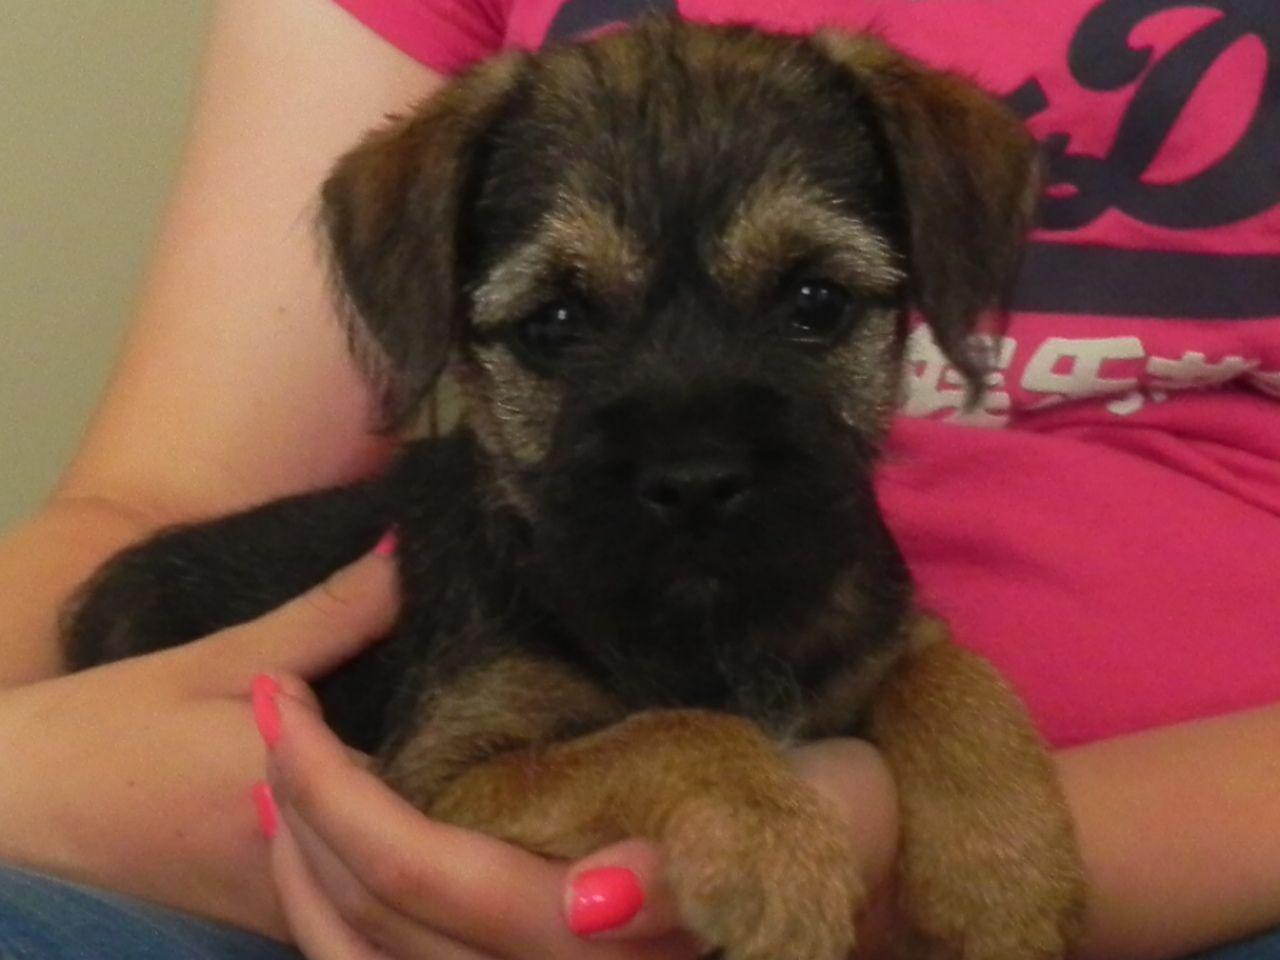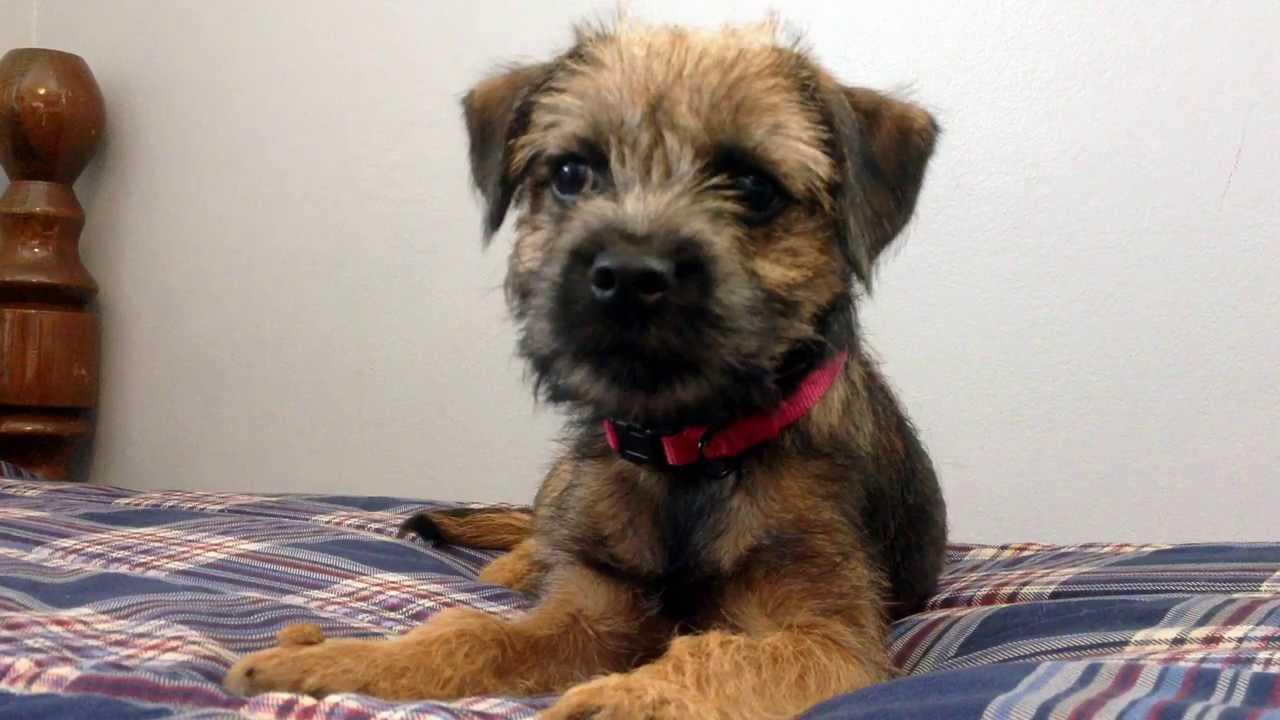The first image is the image on the left, the second image is the image on the right. Analyze the images presented: Is the assertion "One image shows a puppy held in a pair of hands, with its front paws draped over a hand." valid? Answer yes or no. Yes. The first image is the image on the left, the second image is the image on the right. Considering the images on both sides, is "The dog in one of the images is being held in a person's hand." valid? Answer yes or no. Yes. 